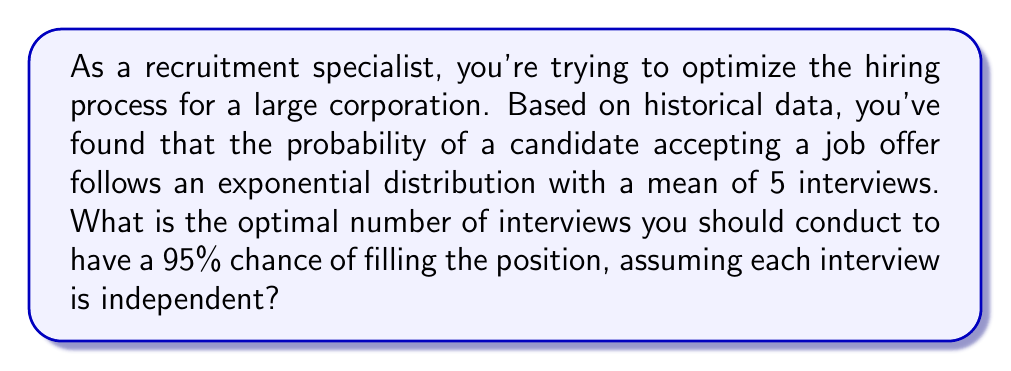Solve this math problem. To solve this problem, we'll use the properties of the exponential distribution and the concept of the cumulative distribution function (CDF).

1) Let $X$ be the number of interviews needed to fill the position. Given that $X$ follows an exponential distribution with mean $\mu = 5$, the rate parameter $\lambda$ is:

   $\lambda = \frac{1}{\mu} = \frac{1}{5}$

2) The CDF of an exponential distribution is given by:

   $F(x) = 1 - e^{-\lambda x}$

3) We want to find $x$ such that $F(x) = 0.95$ (95% chance of filling the position):

   $0.95 = 1 - e^{-\frac{1}{5}x}$

4) Solve for $x$:
   
   $e^{-\frac{1}{5}x} = 1 - 0.95 = 0.05$
   
   $-\frac{1}{5}x = \ln(0.05)$
   
   $x = -5 \ln(0.05)$

5) Calculate the value:

   $x = -5 \ln(0.05) \approx 14.98$

6) Since we can only conduct a whole number of interviews, we round up to the next integer to ensure at least a 95% chance of success.
Answer: The optimal number of interviews to conduct is 15. 